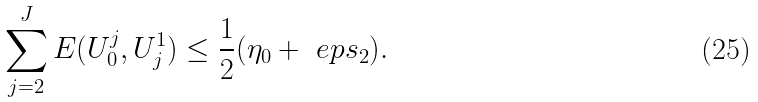<formula> <loc_0><loc_0><loc_500><loc_500>\sum _ { j = 2 } ^ { J } E ( U ^ { j } _ { 0 } , U _ { j } ^ { 1 } ) \leq \frac { 1 } { 2 } ( \eta _ { 0 } + \ e p s _ { 2 } ) .</formula> 